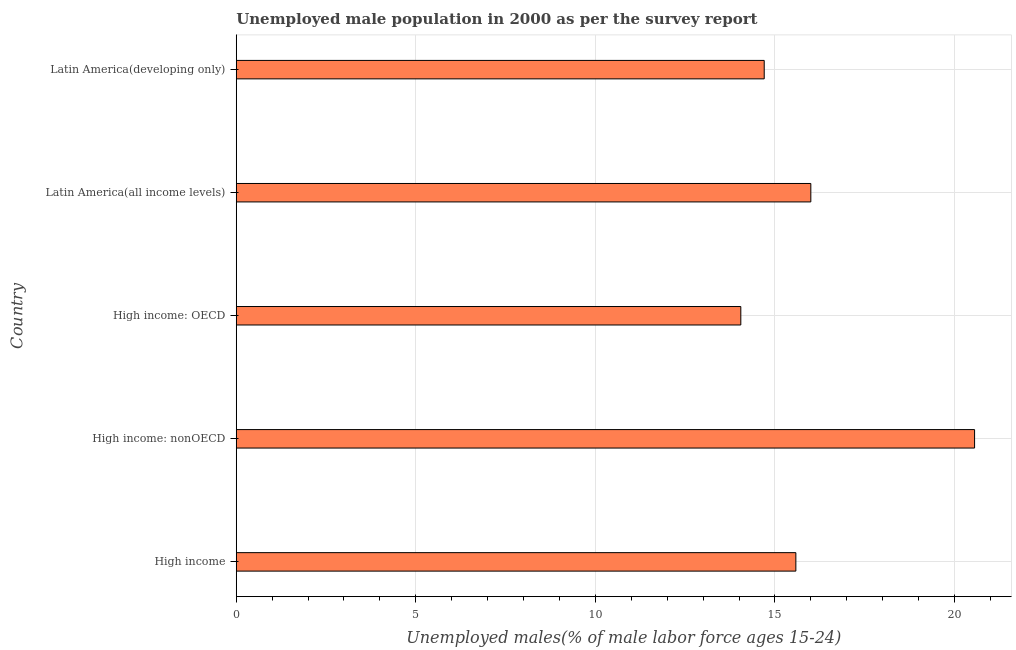What is the title of the graph?
Your answer should be very brief. Unemployed male population in 2000 as per the survey report. What is the label or title of the X-axis?
Offer a terse response. Unemployed males(% of male labor force ages 15-24). What is the unemployed male youth in High income: nonOECD?
Your answer should be compact. 20.56. Across all countries, what is the maximum unemployed male youth?
Ensure brevity in your answer.  20.56. Across all countries, what is the minimum unemployed male youth?
Offer a very short reply. 14.05. In which country was the unemployed male youth maximum?
Keep it short and to the point. High income: nonOECD. In which country was the unemployed male youth minimum?
Give a very brief answer. High income: OECD. What is the sum of the unemployed male youth?
Offer a very short reply. 80.9. What is the difference between the unemployed male youth in High income and Latin America(all income levels)?
Give a very brief answer. -0.42. What is the average unemployed male youth per country?
Ensure brevity in your answer.  16.18. What is the median unemployed male youth?
Your response must be concise. 15.58. What is the ratio of the unemployed male youth in High income: nonOECD to that in Latin America(developing only)?
Keep it short and to the point. 1.4. Is the unemployed male youth in High income less than that in High income: nonOECD?
Give a very brief answer. Yes. What is the difference between the highest and the second highest unemployed male youth?
Your answer should be very brief. 4.56. What is the difference between the highest and the lowest unemployed male youth?
Your response must be concise. 6.51. In how many countries, is the unemployed male youth greater than the average unemployed male youth taken over all countries?
Your response must be concise. 1. Are all the bars in the graph horizontal?
Provide a short and direct response. Yes. How many countries are there in the graph?
Provide a succinct answer. 5. What is the Unemployed males(% of male labor force ages 15-24) of High income?
Ensure brevity in your answer.  15.58. What is the Unemployed males(% of male labor force ages 15-24) of High income: nonOECD?
Ensure brevity in your answer.  20.56. What is the Unemployed males(% of male labor force ages 15-24) in High income: OECD?
Your response must be concise. 14.05. What is the Unemployed males(% of male labor force ages 15-24) in Latin America(all income levels)?
Provide a short and direct response. 16. What is the Unemployed males(% of male labor force ages 15-24) in Latin America(developing only)?
Offer a terse response. 14.7. What is the difference between the Unemployed males(% of male labor force ages 15-24) in High income and High income: nonOECD?
Offer a terse response. -4.98. What is the difference between the Unemployed males(% of male labor force ages 15-24) in High income and High income: OECD?
Ensure brevity in your answer.  1.53. What is the difference between the Unemployed males(% of male labor force ages 15-24) in High income and Latin America(all income levels)?
Offer a terse response. -0.42. What is the difference between the Unemployed males(% of male labor force ages 15-24) in High income and Latin America(developing only)?
Ensure brevity in your answer.  0.88. What is the difference between the Unemployed males(% of male labor force ages 15-24) in High income: nonOECD and High income: OECD?
Your answer should be compact. 6.51. What is the difference between the Unemployed males(% of male labor force ages 15-24) in High income: nonOECD and Latin America(all income levels)?
Your answer should be very brief. 4.56. What is the difference between the Unemployed males(% of male labor force ages 15-24) in High income: nonOECD and Latin America(developing only)?
Make the answer very short. 5.86. What is the difference between the Unemployed males(% of male labor force ages 15-24) in High income: OECD and Latin America(all income levels)?
Ensure brevity in your answer.  -1.95. What is the difference between the Unemployed males(% of male labor force ages 15-24) in High income: OECD and Latin America(developing only)?
Your answer should be very brief. -0.65. What is the difference between the Unemployed males(% of male labor force ages 15-24) in Latin America(all income levels) and Latin America(developing only)?
Ensure brevity in your answer.  1.3. What is the ratio of the Unemployed males(% of male labor force ages 15-24) in High income to that in High income: nonOECD?
Keep it short and to the point. 0.76. What is the ratio of the Unemployed males(% of male labor force ages 15-24) in High income to that in High income: OECD?
Provide a succinct answer. 1.11. What is the ratio of the Unemployed males(% of male labor force ages 15-24) in High income to that in Latin America(all income levels)?
Offer a terse response. 0.97. What is the ratio of the Unemployed males(% of male labor force ages 15-24) in High income to that in Latin America(developing only)?
Offer a terse response. 1.06. What is the ratio of the Unemployed males(% of male labor force ages 15-24) in High income: nonOECD to that in High income: OECD?
Make the answer very short. 1.46. What is the ratio of the Unemployed males(% of male labor force ages 15-24) in High income: nonOECD to that in Latin America(all income levels)?
Your response must be concise. 1.28. What is the ratio of the Unemployed males(% of male labor force ages 15-24) in High income: nonOECD to that in Latin America(developing only)?
Ensure brevity in your answer.  1.4. What is the ratio of the Unemployed males(% of male labor force ages 15-24) in High income: OECD to that in Latin America(all income levels)?
Offer a very short reply. 0.88. What is the ratio of the Unemployed males(% of male labor force ages 15-24) in High income: OECD to that in Latin America(developing only)?
Ensure brevity in your answer.  0.96. What is the ratio of the Unemployed males(% of male labor force ages 15-24) in Latin America(all income levels) to that in Latin America(developing only)?
Your answer should be compact. 1.09. 